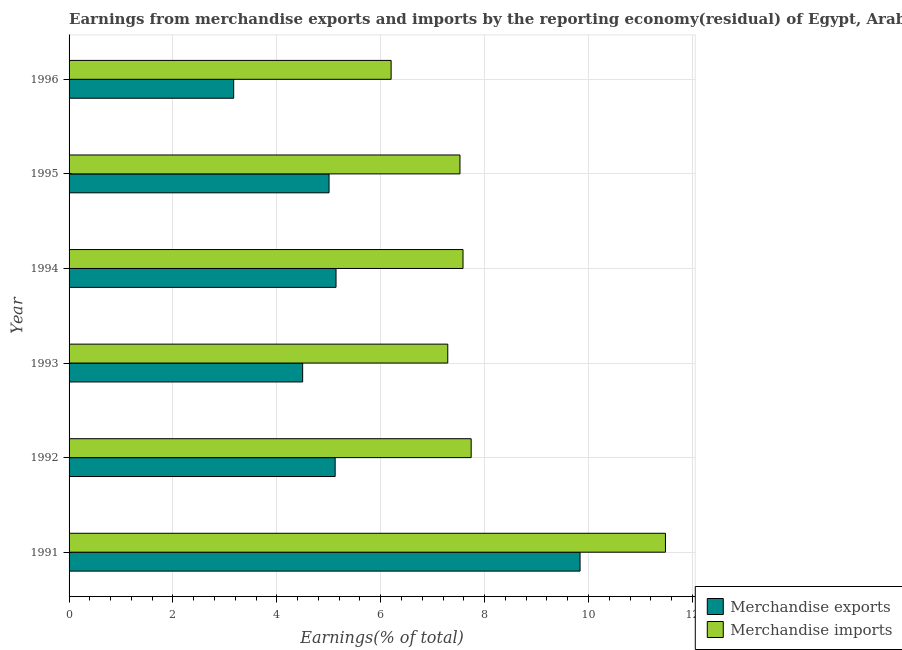How many different coloured bars are there?
Offer a terse response. 2. Are the number of bars per tick equal to the number of legend labels?
Make the answer very short. Yes. How many bars are there on the 6th tick from the top?
Your answer should be very brief. 2. In how many cases, is the number of bars for a given year not equal to the number of legend labels?
Your response must be concise. 0. What is the earnings from merchandise exports in 1993?
Offer a very short reply. 4.5. Across all years, what is the maximum earnings from merchandise imports?
Provide a succinct answer. 11.48. Across all years, what is the minimum earnings from merchandise exports?
Your answer should be very brief. 3.17. What is the total earnings from merchandise exports in the graph?
Keep it short and to the point. 32.77. What is the difference between the earnings from merchandise imports in 1991 and that in 1992?
Offer a very short reply. 3.74. What is the difference between the earnings from merchandise exports in 1991 and the earnings from merchandise imports in 1996?
Give a very brief answer. 3.64. What is the average earnings from merchandise exports per year?
Provide a succinct answer. 5.46. In the year 1991, what is the difference between the earnings from merchandise exports and earnings from merchandise imports?
Provide a short and direct response. -1.64. What is the ratio of the earnings from merchandise exports in 1991 to that in 1992?
Offer a terse response. 1.92. Is the earnings from merchandise exports in 1992 less than that in 1996?
Your response must be concise. No. Is the difference between the earnings from merchandise exports in 1992 and 1995 greater than the difference between the earnings from merchandise imports in 1992 and 1995?
Provide a succinct answer. No. What is the difference between the highest and the second highest earnings from merchandise exports?
Make the answer very short. 4.7. What is the difference between the highest and the lowest earnings from merchandise imports?
Provide a succinct answer. 5.28. In how many years, is the earnings from merchandise exports greater than the average earnings from merchandise exports taken over all years?
Ensure brevity in your answer.  1. What does the 2nd bar from the top in 1991 represents?
Your answer should be compact. Merchandise exports. How many bars are there?
Your response must be concise. 12. How many years are there in the graph?
Provide a short and direct response. 6. What is the difference between two consecutive major ticks on the X-axis?
Ensure brevity in your answer.  2. Does the graph contain any zero values?
Offer a terse response. No. Where does the legend appear in the graph?
Your response must be concise. Bottom right. What is the title of the graph?
Your response must be concise. Earnings from merchandise exports and imports by the reporting economy(residual) of Egypt, Arab Rep. Does "Female population" appear as one of the legend labels in the graph?
Your answer should be compact. No. What is the label or title of the X-axis?
Your response must be concise. Earnings(% of total). What is the label or title of the Y-axis?
Your answer should be compact. Year. What is the Earnings(% of total) of Merchandise exports in 1991?
Make the answer very short. 9.84. What is the Earnings(% of total) in Merchandise imports in 1991?
Your answer should be very brief. 11.48. What is the Earnings(% of total) of Merchandise exports in 1992?
Provide a short and direct response. 5.12. What is the Earnings(% of total) of Merchandise imports in 1992?
Provide a succinct answer. 7.74. What is the Earnings(% of total) in Merchandise exports in 1993?
Ensure brevity in your answer.  4.5. What is the Earnings(% of total) of Merchandise imports in 1993?
Offer a very short reply. 7.29. What is the Earnings(% of total) of Merchandise exports in 1994?
Your answer should be compact. 5.14. What is the Earnings(% of total) in Merchandise imports in 1994?
Offer a very short reply. 7.58. What is the Earnings(% of total) in Merchandise exports in 1995?
Offer a terse response. 5.01. What is the Earnings(% of total) of Merchandise imports in 1995?
Keep it short and to the point. 7.53. What is the Earnings(% of total) in Merchandise exports in 1996?
Provide a succinct answer. 3.17. What is the Earnings(% of total) of Merchandise imports in 1996?
Your answer should be very brief. 6.2. Across all years, what is the maximum Earnings(% of total) of Merchandise exports?
Ensure brevity in your answer.  9.84. Across all years, what is the maximum Earnings(% of total) of Merchandise imports?
Your response must be concise. 11.48. Across all years, what is the minimum Earnings(% of total) in Merchandise exports?
Your response must be concise. 3.17. Across all years, what is the minimum Earnings(% of total) of Merchandise imports?
Your answer should be very brief. 6.2. What is the total Earnings(% of total) of Merchandise exports in the graph?
Offer a very short reply. 32.77. What is the total Earnings(% of total) of Merchandise imports in the graph?
Your answer should be very brief. 47.82. What is the difference between the Earnings(% of total) in Merchandise exports in 1991 and that in 1992?
Make the answer very short. 4.72. What is the difference between the Earnings(% of total) in Merchandise imports in 1991 and that in 1992?
Ensure brevity in your answer.  3.74. What is the difference between the Earnings(% of total) of Merchandise exports in 1991 and that in 1993?
Provide a succinct answer. 5.34. What is the difference between the Earnings(% of total) in Merchandise imports in 1991 and that in 1993?
Your answer should be compact. 4.19. What is the difference between the Earnings(% of total) in Merchandise exports in 1991 and that in 1994?
Offer a very short reply. 4.7. What is the difference between the Earnings(% of total) in Merchandise imports in 1991 and that in 1994?
Your answer should be compact. 3.9. What is the difference between the Earnings(% of total) of Merchandise exports in 1991 and that in 1995?
Keep it short and to the point. 4.83. What is the difference between the Earnings(% of total) of Merchandise imports in 1991 and that in 1995?
Give a very brief answer. 3.96. What is the difference between the Earnings(% of total) of Merchandise exports in 1991 and that in 1996?
Your response must be concise. 6.67. What is the difference between the Earnings(% of total) in Merchandise imports in 1991 and that in 1996?
Give a very brief answer. 5.28. What is the difference between the Earnings(% of total) in Merchandise exports in 1992 and that in 1993?
Your answer should be compact. 0.63. What is the difference between the Earnings(% of total) of Merchandise imports in 1992 and that in 1993?
Make the answer very short. 0.45. What is the difference between the Earnings(% of total) in Merchandise exports in 1992 and that in 1994?
Ensure brevity in your answer.  -0.02. What is the difference between the Earnings(% of total) of Merchandise imports in 1992 and that in 1994?
Offer a very short reply. 0.16. What is the difference between the Earnings(% of total) of Merchandise exports in 1992 and that in 1995?
Ensure brevity in your answer.  0.12. What is the difference between the Earnings(% of total) of Merchandise imports in 1992 and that in 1995?
Provide a succinct answer. 0.22. What is the difference between the Earnings(% of total) in Merchandise exports in 1992 and that in 1996?
Your answer should be very brief. 1.95. What is the difference between the Earnings(% of total) of Merchandise imports in 1992 and that in 1996?
Provide a short and direct response. 1.54. What is the difference between the Earnings(% of total) in Merchandise exports in 1993 and that in 1994?
Keep it short and to the point. -0.64. What is the difference between the Earnings(% of total) in Merchandise imports in 1993 and that in 1994?
Give a very brief answer. -0.29. What is the difference between the Earnings(% of total) in Merchandise exports in 1993 and that in 1995?
Keep it short and to the point. -0.51. What is the difference between the Earnings(% of total) in Merchandise imports in 1993 and that in 1995?
Provide a succinct answer. -0.23. What is the difference between the Earnings(% of total) of Merchandise exports in 1993 and that in 1996?
Your answer should be very brief. 1.33. What is the difference between the Earnings(% of total) in Merchandise imports in 1993 and that in 1996?
Provide a short and direct response. 1.09. What is the difference between the Earnings(% of total) in Merchandise exports in 1994 and that in 1995?
Provide a short and direct response. 0.13. What is the difference between the Earnings(% of total) of Merchandise imports in 1994 and that in 1995?
Ensure brevity in your answer.  0.06. What is the difference between the Earnings(% of total) in Merchandise exports in 1994 and that in 1996?
Provide a succinct answer. 1.97. What is the difference between the Earnings(% of total) of Merchandise imports in 1994 and that in 1996?
Your response must be concise. 1.38. What is the difference between the Earnings(% of total) in Merchandise exports in 1995 and that in 1996?
Provide a short and direct response. 1.84. What is the difference between the Earnings(% of total) of Merchandise imports in 1995 and that in 1996?
Provide a succinct answer. 1.33. What is the difference between the Earnings(% of total) in Merchandise exports in 1991 and the Earnings(% of total) in Merchandise imports in 1992?
Provide a short and direct response. 2.1. What is the difference between the Earnings(% of total) of Merchandise exports in 1991 and the Earnings(% of total) of Merchandise imports in 1993?
Your answer should be compact. 2.55. What is the difference between the Earnings(% of total) of Merchandise exports in 1991 and the Earnings(% of total) of Merchandise imports in 1994?
Your answer should be very brief. 2.25. What is the difference between the Earnings(% of total) of Merchandise exports in 1991 and the Earnings(% of total) of Merchandise imports in 1995?
Your response must be concise. 2.31. What is the difference between the Earnings(% of total) of Merchandise exports in 1991 and the Earnings(% of total) of Merchandise imports in 1996?
Keep it short and to the point. 3.64. What is the difference between the Earnings(% of total) in Merchandise exports in 1992 and the Earnings(% of total) in Merchandise imports in 1993?
Give a very brief answer. -2.17. What is the difference between the Earnings(% of total) in Merchandise exports in 1992 and the Earnings(% of total) in Merchandise imports in 1994?
Your answer should be very brief. -2.46. What is the difference between the Earnings(% of total) of Merchandise exports in 1992 and the Earnings(% of total) of Merchandise imports in 1995?
Make the answer very short. -2.4. What is the difference between the Earnings(% of total) of Merchandise exports in 1992 and the Earnings(% of total) of Merchandise imports in 1996?
Your answer should be very brief. -1.08. What is the difference between the Earnings(% of total) of Merchandise exports in 1993 and the Earnings(% of total) of Merchandise imports in 1994?
Make the answer very short. -3.09. What is the difference between the Earnings(% of total) in Merchandise exports in 1993 and the Earnings(% of total) in Merchandise imports in 1995?
Ensure brevity in your answer.  -3.03. What is the difference between the Earnings(% of total) of Merchandise exports in 1993 and the Earnings(% of total) of Merchandise imports in 1996?
Make the answer very short. -1.7. What is the difference between the Earnings(% of total) of Merchandise exports in 1994 and the Earnings(% of total) of Merchandise imports in 1995?
Your answer should be compact. -2.39. What is the difference between the Earnings(% of total) of Merchandise exports in 1994 and the Earnings(% of total) of Merchandise imports in 1996?
Make the answer very short. -1.06. What is the difference between the Earnings(% of total) of Merchandise exports in 1995 and the Earnings(% of total) of Merchandise imports in 1996?
Make the answer very short. -1.2. What is the average Earnings(% of total) of Merchandise exports per year?
Keep it short and to the point. 5.46. What is the average Earnings(% of total) of Merchandise imports per year?
Give a very brief answer. 7.97. In the year 1991, what is the difference between the Earnings(% of total) in Merchandise exports and Earnings(% of total) in Merchandise imports?
Offer a terse response. -1.64. In the year 1992, what is the difference between the Earnings(% of total) in Merchandise exports and Earnings(% of total) in Merchandise imports?
Offer a terse response. -2.62. In the year 1993, what is the difference between the Earnings(% of total) of Merchandise exports and Earnings(% of total) of Merchandise imports?
Offer a terse response. -2.79. In the year 1994, what is the difference between the Earnings(% of total) in Merchandise exports and Earnings(% of total) in Merchandise imports?
Give a very brief answer. -2.44. In the year 1995, what is the difference between the Earnings(% of total) in Merchandise exports and Earnings(% of total) in Merchandise imports?
Your answer should be very brief. -2.52. In the year 1996, what is the difference between the Earnings(% of total) of Merchandise exports and Earnings(% of total) of Merchandise imports?
Your response must be concise. -3.03. What is the ratio of the Earnings(% of total) of Merchandise exports in 1991 to that in 1992?
Your answer should be compact. 1.92. What is the ratio of the Earnings(% of total) in Merchandise imports in 1991 to that in 1992?
Offer a very short reply. 1.48. What is the ratio of the Earnings(% of total) in Merchandise exports in 1991 to that in 1993?
Give a very brief answer. 2.19. What is the ratio of the Earnings(% of total) of Merchandise imports in 1991 to that in 1993?
Give a very brief answer. 1.57. What is the ratio of the Earnings(% of total) of Merchandise exports in 1991 to that in 1994?
Provide a succinct answer. 1.91. What is the ratio of the Earnings(% of total) of Merchandise imports in 1991 to that in 1994?
Give a very brief answer. 1.51. What is the ratio of the Earnings(% of total) in Merchandise exports in 1991 to that in 1995?
Give a very brief answer. 1.97. What is the ratio of the Earnings(% of total) in Merchandise imports in 1991 to that in 1995?
Make the answer very short. 1.53. What is the ratio of the Earnings(% of total) of Merchandise exports in 1991 to that in 1996?
Keep it short and to the point. 3.1. What is the ratio of the Earnings(% of total) in Merchandise imports in 1991 to that in 1996?
Your answer should be compact. 1.85. What is the ratio of the Earnings(% of total) of Merchandise exports in 1992 to that in 1993?
Your answer should be compact. 1.14. What is the ratio of the Earnings(% of total) of Merchandise imports in 1992 to that in 1993?
Give a very brief answer. 1.06. What is the ratio of the Earnings(% of total) of Merchandise exports in 1992 to that in 1994?
Offer a terse response. 1. What is the ratio of the Earnings(% of total) of Merchandise imports in 1992 to that in 1994?
Provide a succinct answer. 1.02. What is the ratio of the Earnings(% of total) of Merchandise exports in 1992 to that in 1995?
Provide a short and direct response. 1.02. What is the ratio of the Earnings(% of total) of Merchandise imports in 1992 to that in 1995?
Your answer should be compact. 1.03. What is the ratio of the Earnings(% of total) of Merchandise exports in 1992 to that in 1996?
Offer a terse response. 1.62. What is the ratio of the Earnings(% of total) in Merchandise imports in 1992 to that in 1996?
Offer a terse response. 1.25. What is the ratio of the Earnings(% of total) in Merchandise imports in 1993 to that in 1994?
Provide a succinct answer. 0.96. What is the ratio of the Earnings(% of total) of Merchandise exports in 1993 to that in 1995?
Provide a succinct answer. 0.9. What is the ratio of the Earnings(% of total) of Merchandise imports in 1993 to that in 1995?
Give a very brief answer. 0.97. What is the ratio of the Earnings(% of total) in Merchandise exports in 1993 to that in 1996?
Provide a short and direct response. 1.42. What is the ratio of the Earnings(% of total) of Merchandise imports in 1993 to that in 1996?
Offer a very short reply. 1.18. What is the ratio of the Earnings(% of total) in Merchandise exports in 1994 to that in 1995?
Give a very brief answer. 1.03. What is the ratio of the Earnings(% of total) in Merchandise imports in 1994 to that in 1995?
Your answer should be very brief. 1.01. What is the ratio of the Earnings(% of total) in Merchandise exports in 1994 to that in 1996?
Provide a succinct answer. 1.62. What is the ratio of the Earnings(% of total) of Merchandise imports in 1994 to that in 1996?
Give a very brief answer. 1.22. What is the ratio of the Earnings(% of total) in Merchandise exports in 1995 to that in 1996?
Ensure brevity in your answer.  1.58. What is the ratio of the Earnings(% of total) in Merchandise imports in 1995 to that in 1996?
Make the answer very short. 1.21. What is the difference between the highest and the second highest Earnings(% of total) in Merchandise exports?
Offer a terse response. 4.7. What is the difference between the highest and the second highest Earnings(% of total) of Merchandise imports?
Ensure brevity in your answer.  3.74. What is the difference between the highest and the lowest Earnings(% of total) in Merchandise exports?
Give a very brief answer. 6.67. What is the difference between the highest and the lowest Earnings(% of total) of Merchandise imports?
Your answer should be very brief. 5.28. 